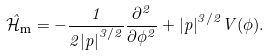Convert formula to latex. <formula><loc_0><loc_0><loc_500><loc_500>\hat { \mathcal { H } } _ { \text {m} } = - \frac { 1 } { 2 { | p | } ^ { 3 / 2 } } \frac { \partial ^ { 2 } } { \partial \phi ^ { 2 } } + { | p | } ^ { 3 / 2 } V ( \phi ) .</formula> 